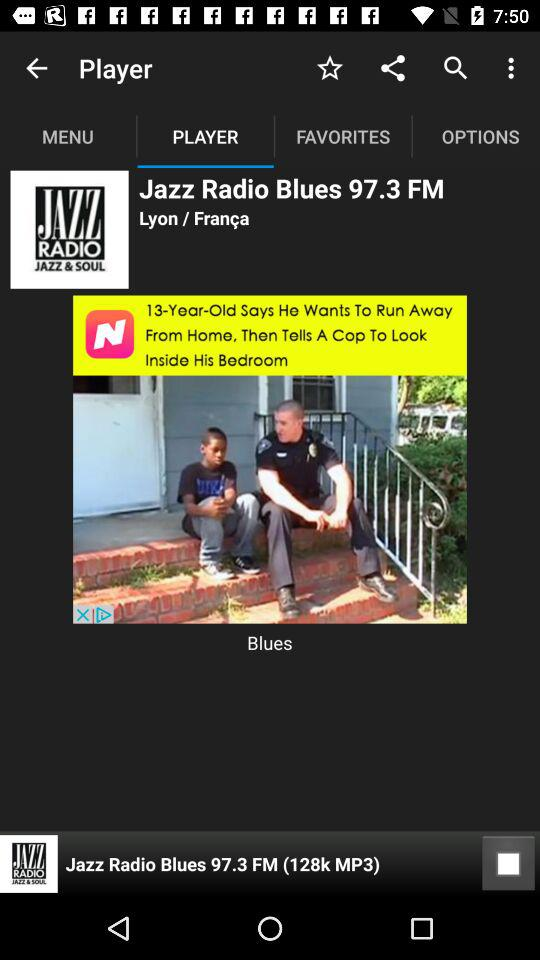What is the name of the radio song on the player? The name of the radio song is "Jazz Radio Blues 97.3 FM". 